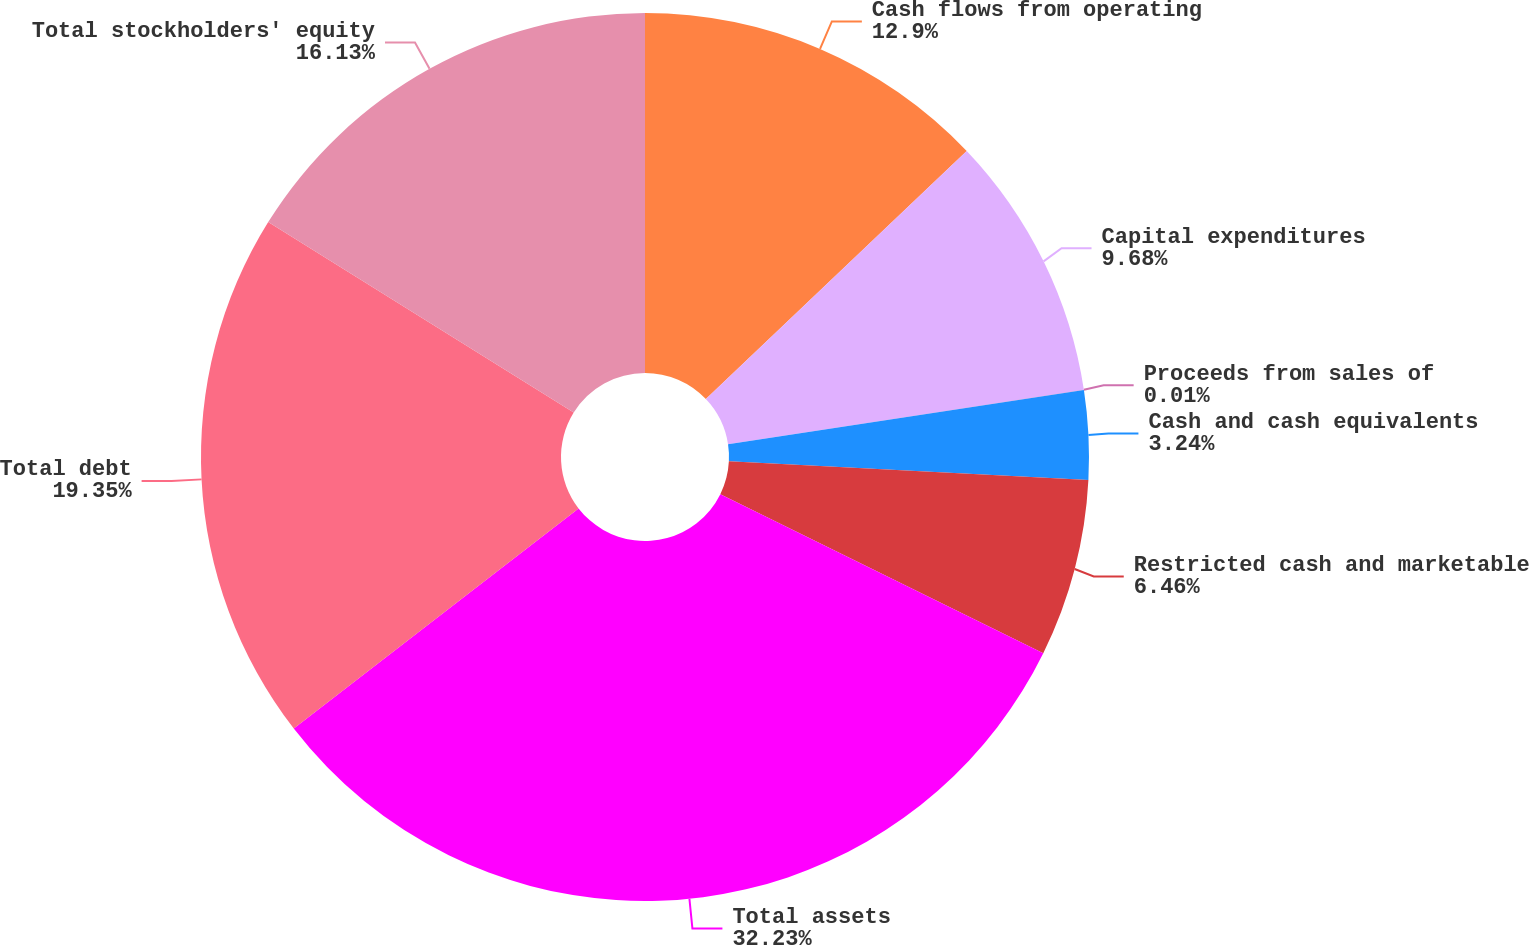<chart> <loc_0><loc_0><loc_500><loc_500><pie_chart><fcel>Cash flows from operating<fcel>Capital expenditures<fcel>Proceeds from sales of<fcel>Cash and cash equivalents<fcel>Restricted cash and marketable<fcel>Total assets<fcel>Total debt<fcel>Total stockholders' equity<nl><fcel>12.9%<fcel>9.68%<fcel>0.01%<fcel>3.24%<fcel>6.46%<fcel>32.24%<fcel>19.35%<fcel>16.13%<nl></chart> 